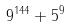Convert formula to latex. <formula><loc_0><loc_0><loc_500><loc_500>9 ^ { 1 4 4 } + 5 ^ { 9 }</formula> 